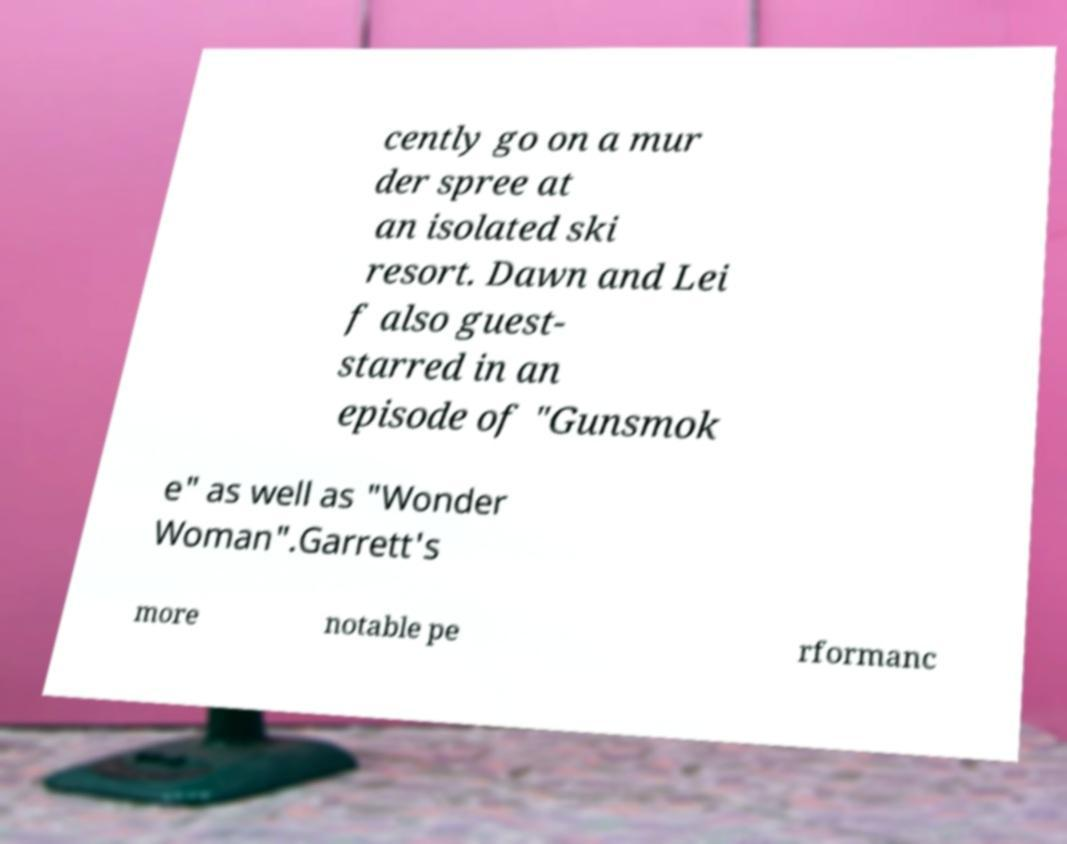Could you assist in decoding the text presented in this image and type it out clearly? cently go on a mur der spree at an isolated ski resort. Dawn and Lei f also guest- starred in an episode of "Gunsmok e" as well as "Wonder Woman".Garrett's more notable pe rformanc 